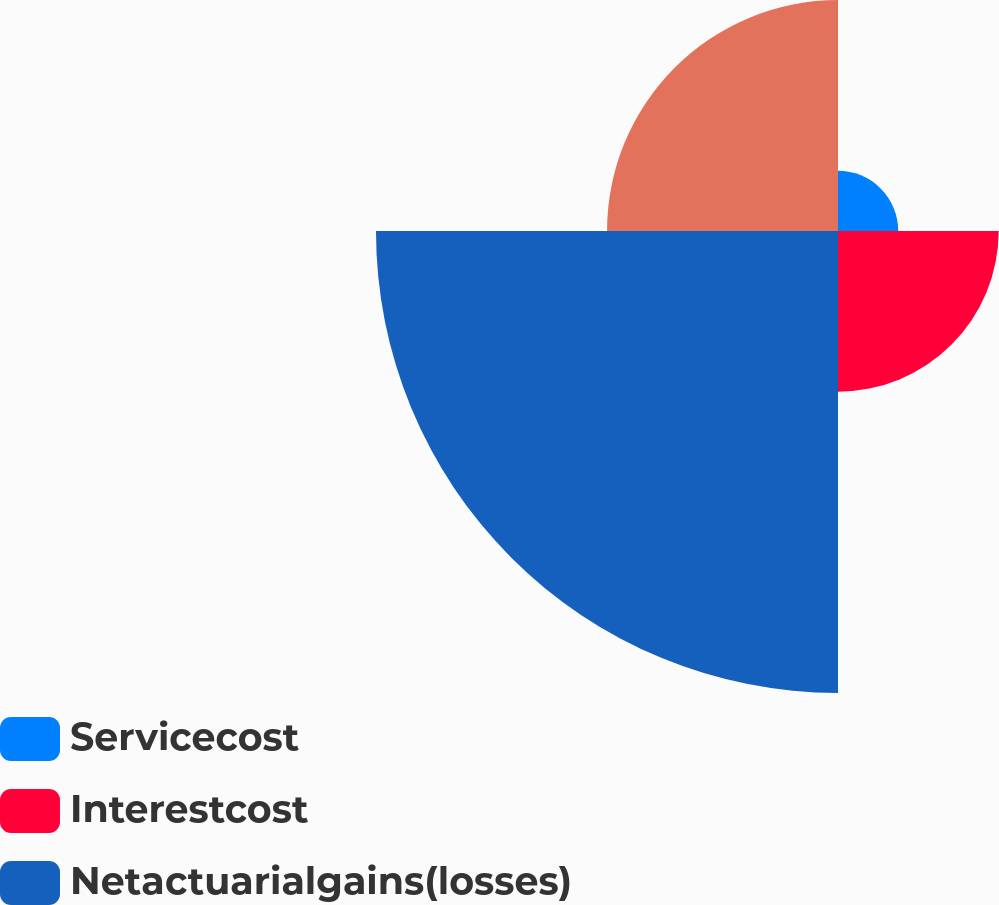Convert chart to OTSL. <chart><loc_0><loc_0><loc_500><loc_500><pie_chart><fcel>Servicecost<fcel>Interestcost<fcel>Netactuarialgains(losses)<fcel>Unnamed: 3<nl><fcel>6.59%<fcel>17.58%<fcel>50.55%<fcel>25.27%<nl></chart> 